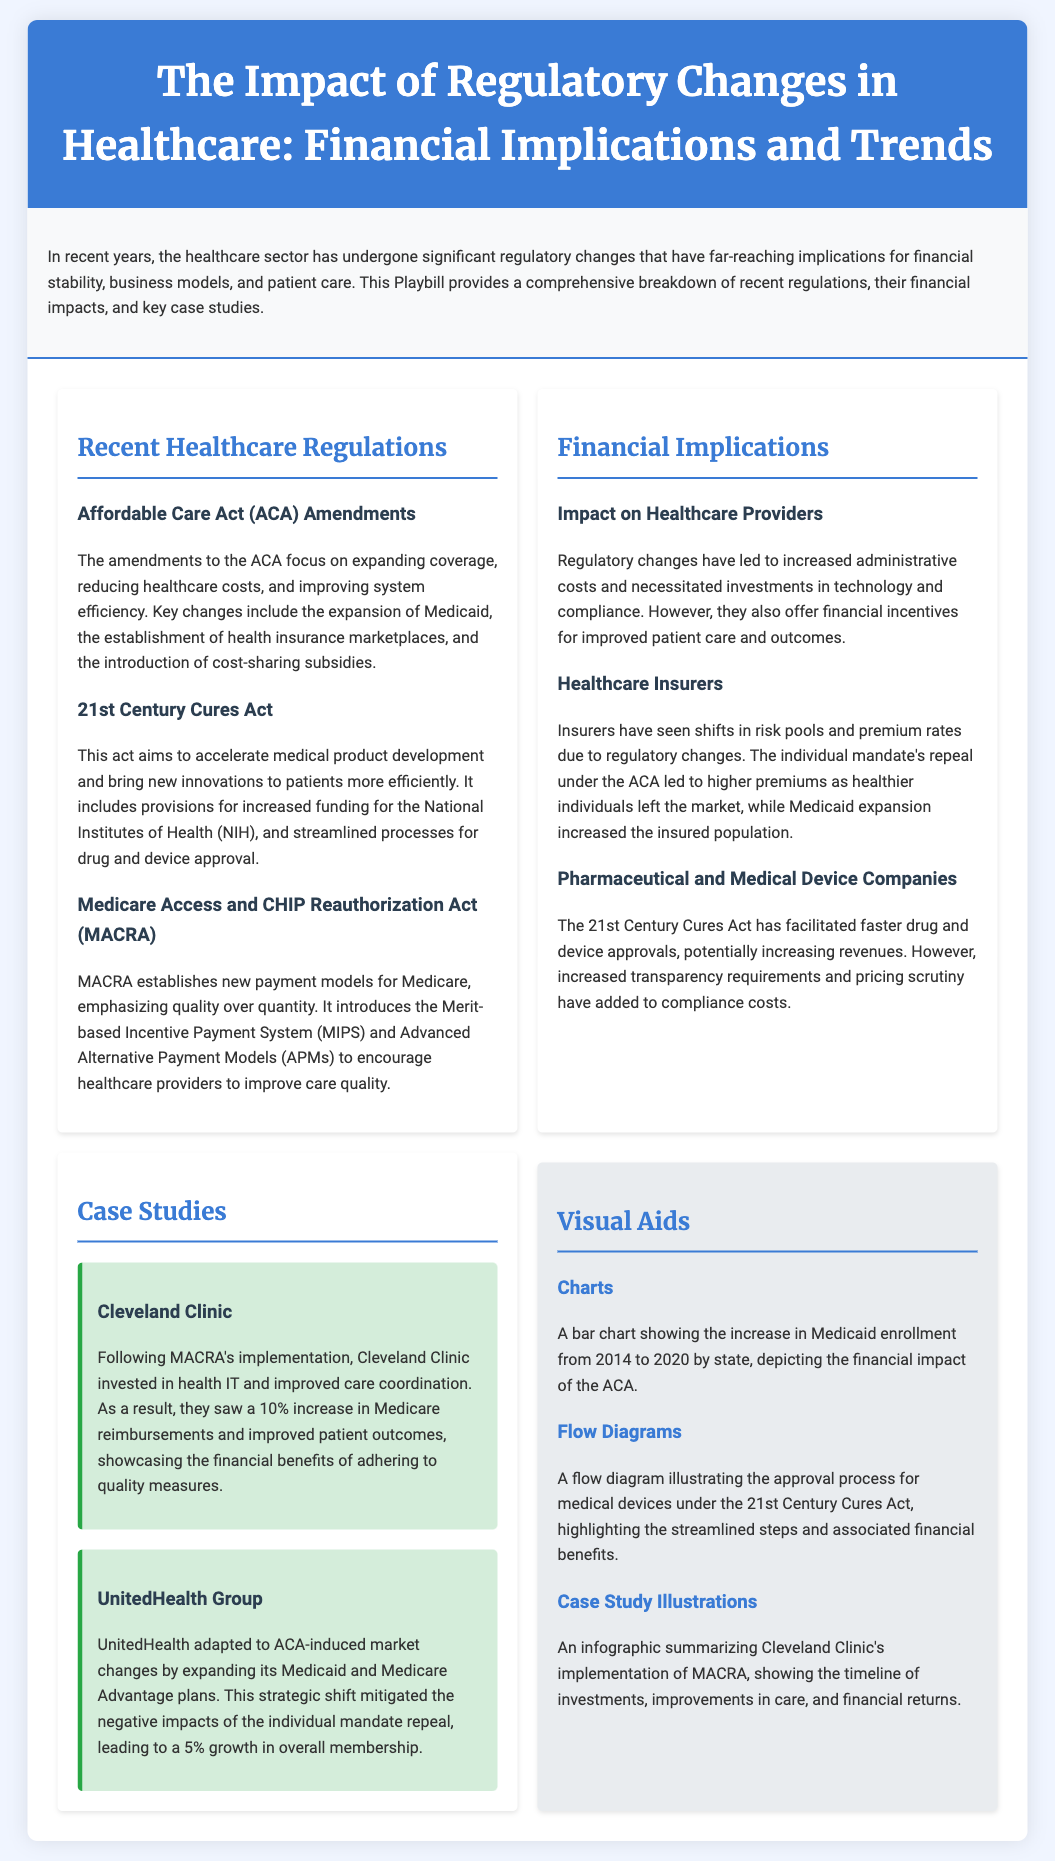What is the title of the document? The title is the main heading of the Playbill that summarizes its focus on healthcare regulatory changes and their impacts.
Answer: The Impact of Regulatory Changes in Healthcare: Financial Implications and Trends What act aims to accelerate medical product development? The document names the 21st Century Cures Act specifically as the act designed for this purpose.
Answer: 21st Century Cures Act What new payment system does MACRA introduce? The Merit-based Incentive Payment System (MIPS) is mentioned as part of the new payment models established by MACRA.
Answer: Merit-based Incentive Payment System (MIPS) What percentage increase in Medicare reimbursements did Cleveland Clinic achieve? The document states a specific percentage to highlight the positive financial impact following MACRA's implementation at Cleveland Clinic.
Answer: 10% How much growth in overall membership did UnitedHealth Group experience? This question targets the direct impact of strategic moves in response to ACA changes mentioned in the case study about UnitedHealth Group.
Answer: 5% What was a key goal of the Affordable Care Act amendments? The ACA's goal is to expand coverage, which is a primary focus in discussing the act's implications.
Answer: Expanding coverage Which visual aid illustrates the approval process for medical devices? The flow diagram is specifically referenced in the document as a type of visual aid illustrating this process.
Answer: Flow diagram What type of chart shows Medicaid enrollment increase? The bar chart is identified in the document as representing the increase in Medicaid enrollment over several years.
Answer: Bar chart What company invested in health IT under MACRA? Cleveland Clinic is highlighted as the organization that made this investment, emphasizing their response to regulatory changes.
Answer: Cleveland Clinic 